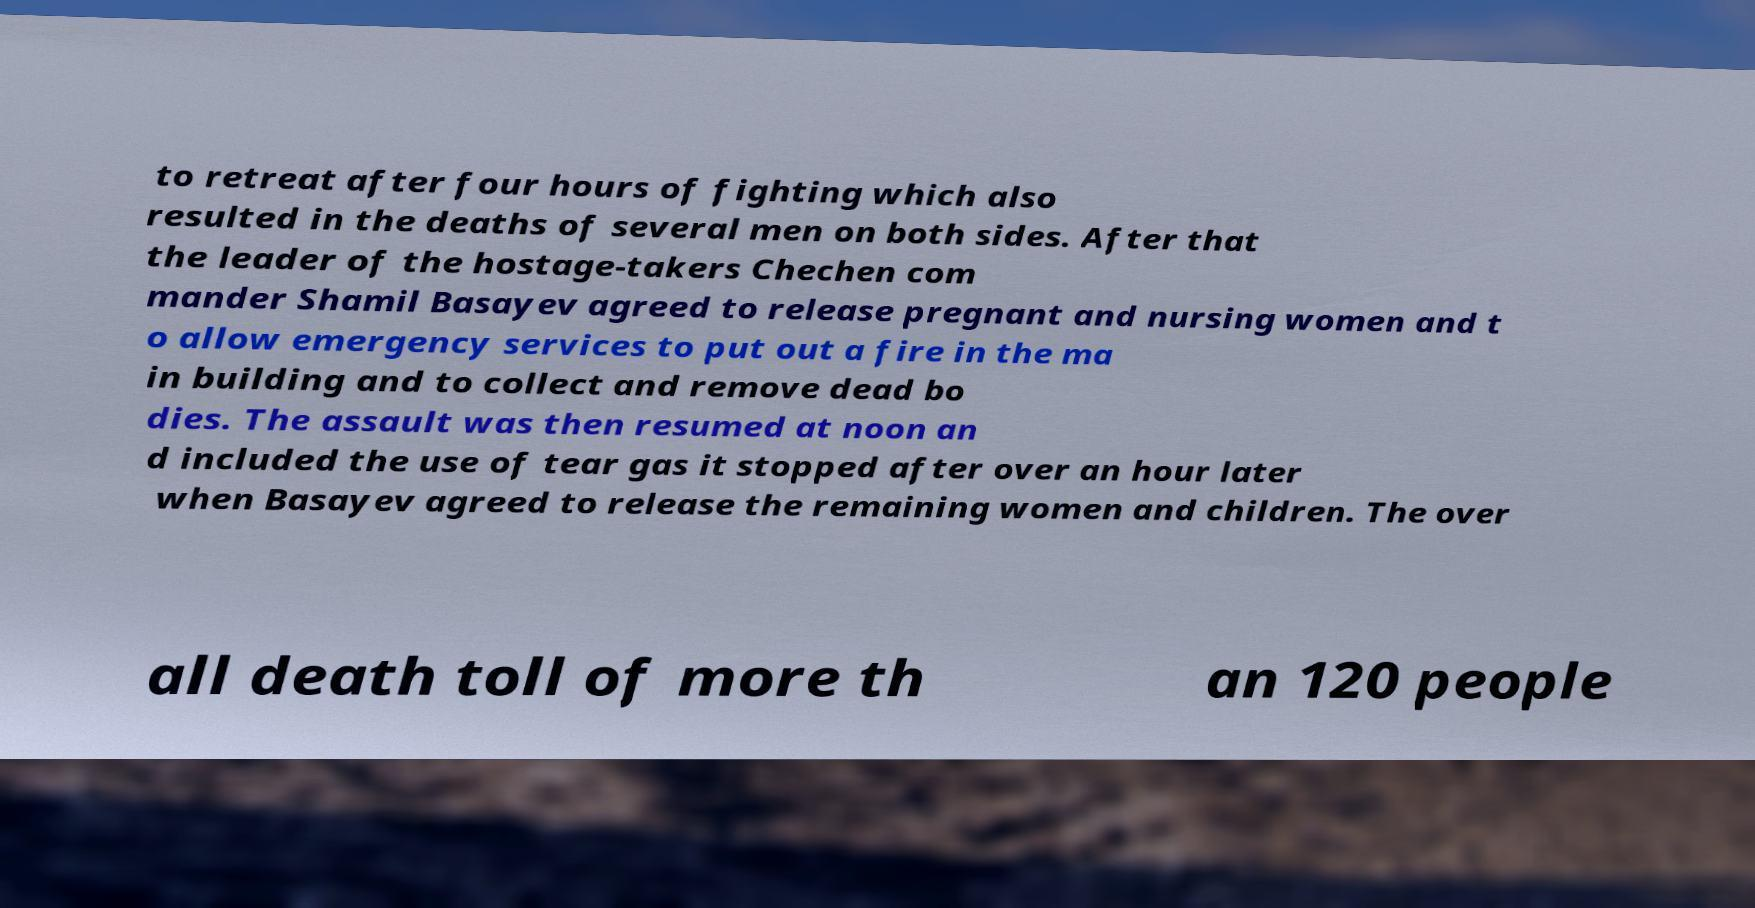Please identify and transcribe the text found in this image. to retreat after four hours of fighting which also resulted in the deaths of several men on both sides. After that the leader of the hostage-takers Chechen com mander Shamil Basayev agreed to release pregnant and nursing women and t o allow emergency services to put out a fire in the ma in building and to collect and remove dead bo dies. The assault was then resumed at noon an d included the use of tear gas it stopped after over an hour later when Basayev agreed to release the remaining women and children. The over all death toll of more th an 120 people 